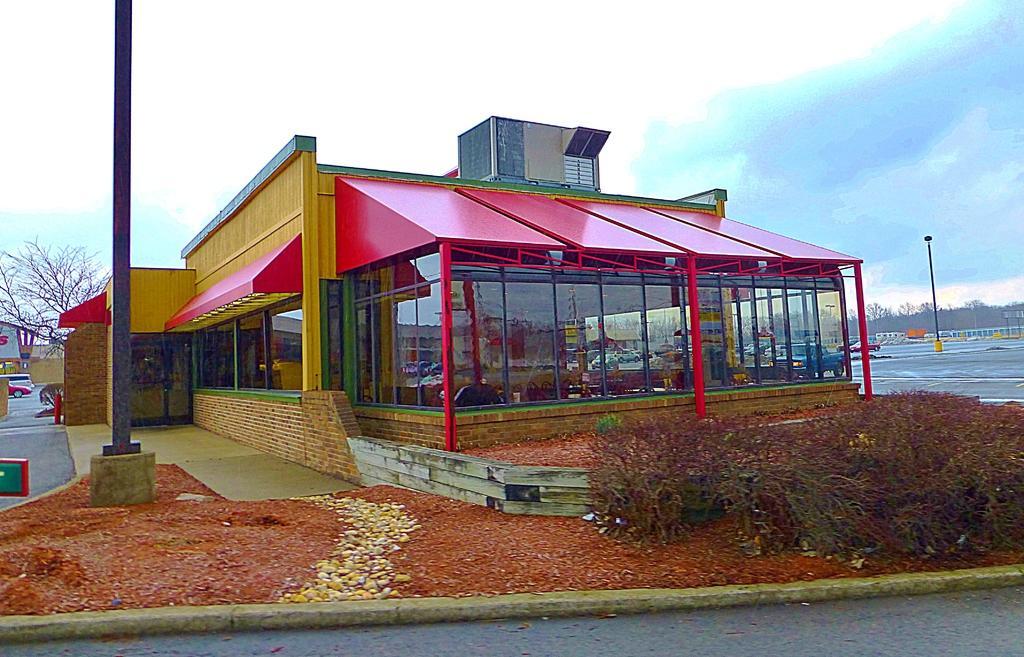In one or two sentences, can you explain what this image depicts? In the foreground of the picture there are shrubs, stones, soil, pole and building. In the background there are trees, vehicles, pole and some buildings. Sky is cloudy. 